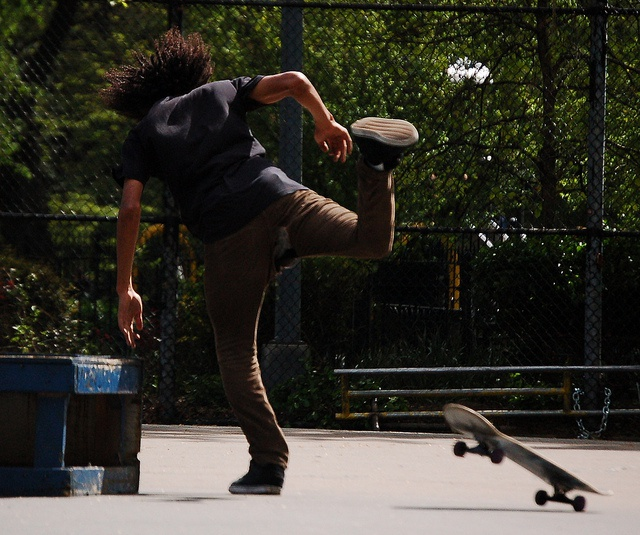Describe the objects in this image and their specific colors. I can see people in black, maroon, gray, and darkgray tones, bench in black, gray, darkgray, and blue tones, and skateboard in black and gray tones in this image. 